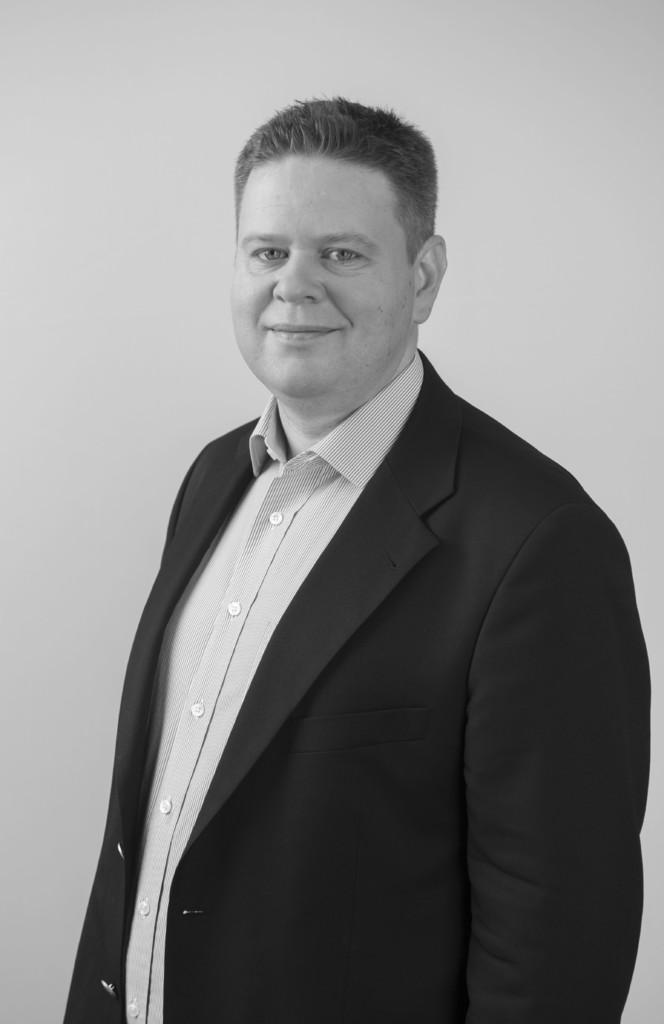How would you summarize this image in a sentence or two? In this image in the front there is a man standing and smiling. 